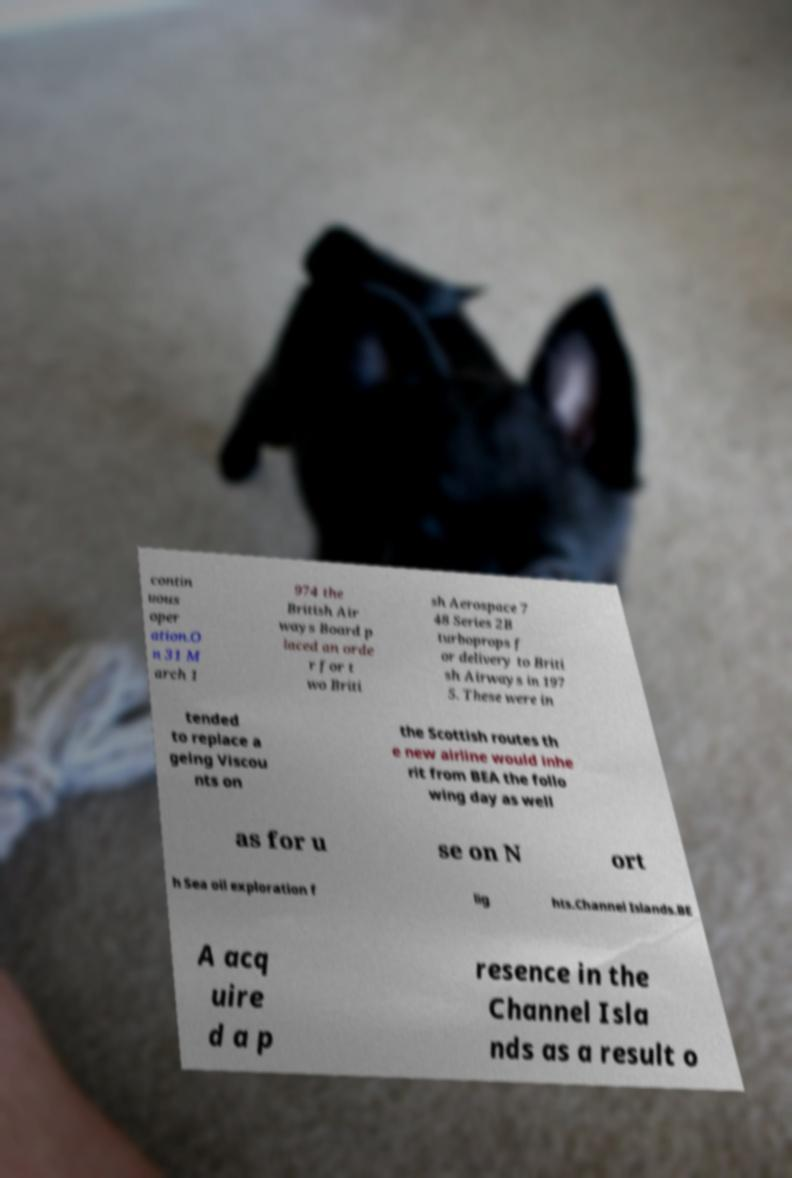Could you extract and type out the text from this image? contin uous oper ation.O n 31 M arch 1 974 the British Air ways Board p laced an orde r for t wo Briti sh Aerospace 7 48 Series 2B turboprops f or delivery to Briti sh Airways in 197 5. These were in tended to replace a geing Viscou nts on the Scottish routes th e new airline would inhe rit from BEA the follo wing day as well as for u se on N ort h Sea oil exploration f lig hts.Channel Islands.BE A acq uire d a p resence in the Channel Isla nds as a result o 